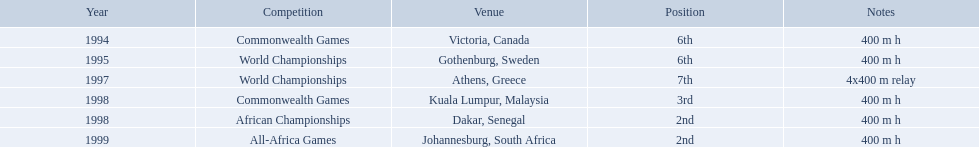What country was the 1997 championships held in? Athens, Greece. What long was the relay? 4x400 m relay. What years did ken harder compete in? 1994, 1995, 1997, 1998, 1998, 1999. For the 1997 relay, what distance was ran? 4x400 m relay. Which country hosted the 1997 championships? Athens, Greece. What was the distance of the relay? 4x400 m relay. In what races was ken harden a competitor? 400 m h, 400 m h, 4x400 m relay, 400 m h, 400 m h, 400 m h. In the year 1997, what race did he take part in? 4x400 m relay. What were the races that ken harden competed in? 400 m h, 400 m h, 4x400 m relay, 400 m h, 400 m h, 400 m h. Which particular race did he enter in 1997? 4x400 m relay. 